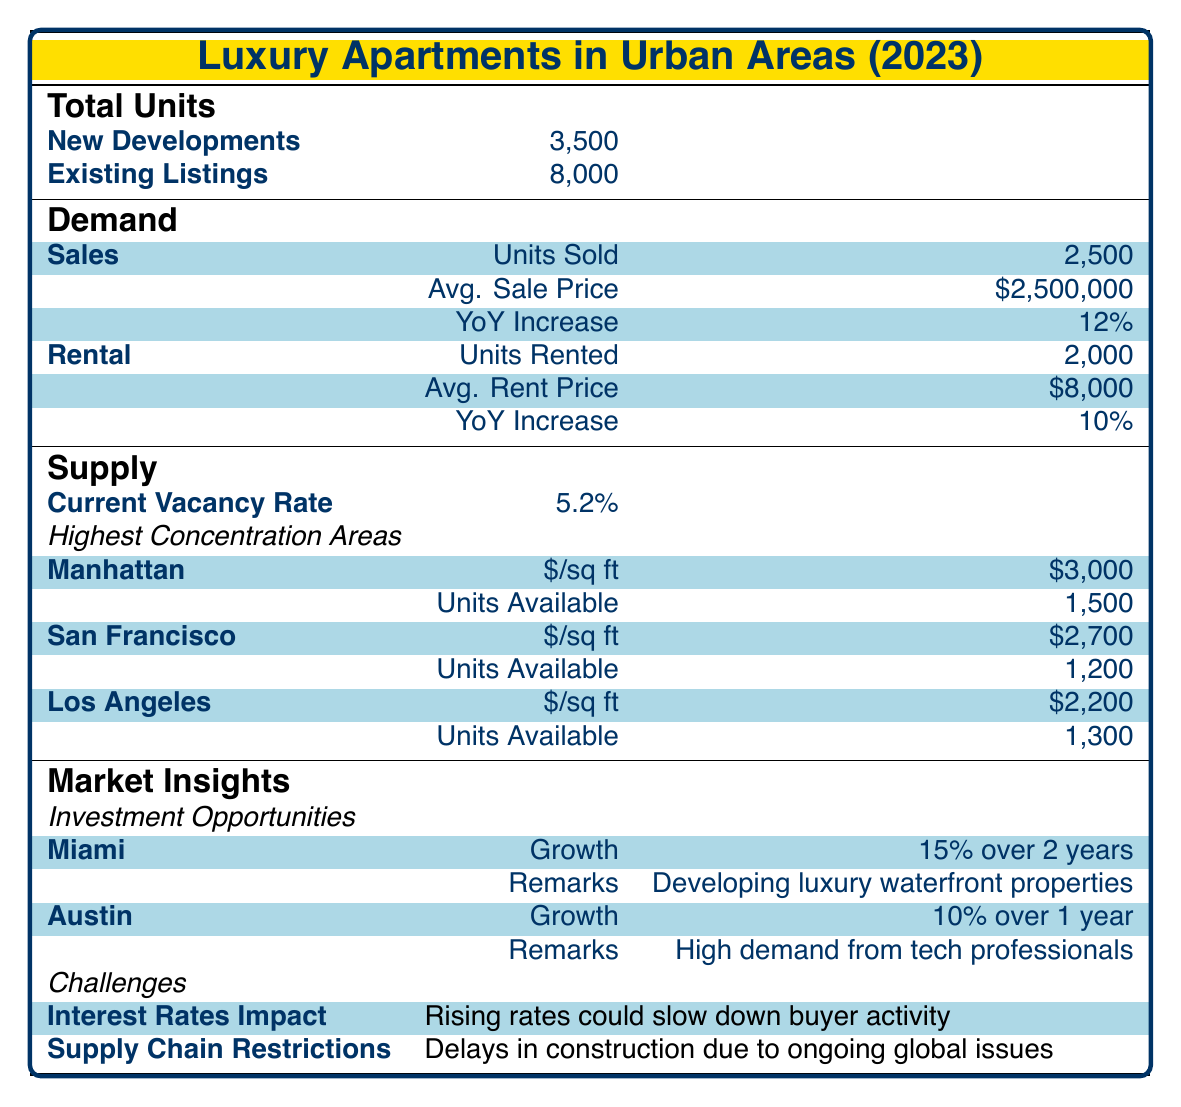What is the total number of luxury apartments listed in 2023? The total number of luxury apartments listed combines both new developments and existing listings. From the table, new developments are 3,500 units and existing listings are 8,000 units. Thus, the total is 3,500 + 8,000 = 11,500 units.
Answer: 11,500 What is the average sale price of luxury apartments sold in 2023? The average sale price is provided directly in the table under the sales demand section. The average sale price for units sold is listed as 2,500,000.
Answer: 2,500,000 Is the current vacancy rate for luxury apartments above or below 5 percent? The current vacancy rate for luxury apartments is listed as 5.2 percent. Since 5.2 percent is greater than 5 percent, the answer is yes, it is above 5 percent.
Answer: Yes What percentage increase in units sold was seen year over year? The percentage increase in units sold year over year is specified in the sales section of demand. It is stated to be 12 percent.
Answer: 12 percent Which urban area has the highest average price per square foot? The table lists the highest concentration areas and their corresponding average prices per square foot. Manhattan's average price per square foot is 3,000, which is higher than San Francisco’s 2,700 and Los Angeles’s 2,200. Therefore, Manhattan has the highest average price per square foot.
Answer: Manhattan What is the total number of luxury apartments rented in 2023? From the rental demand section, the number of units rented is explicitly stated as 2,000.
Answer: 2,000 What is the combined projected growth for luxury apartments in Miami and Austin? To find the combined projected growth, we need to interpret the growth figures provided for both areas. Miami's projected growth is 15 percent over 2 years and Austin's is 10 percent over 1 year. Since these growth percentages are on different timelines, we interpret them separately rather than summing them directly for a single time frame. Thus, while we can recognize their distinct growth rates, they cannot be added together meaningfully without additional context regarding the time period covered.
Answer: Not directly comparable Is the average rent price for luxury apartments increasing or decreasing year over year? The average rent price for luxury apartments is listed as increasing. Specifically, in the table, the year over year increase is noted as 10 percent.
Answer: Increasing What challenges are impacting the luxury apartment market currently? The table lists two challenges affecting the market: rising interest rates, which could slow buyer activity, and supply chain restrictions leading to delays in construction.
Answer: Rising interest rates and supply chain restrictions 